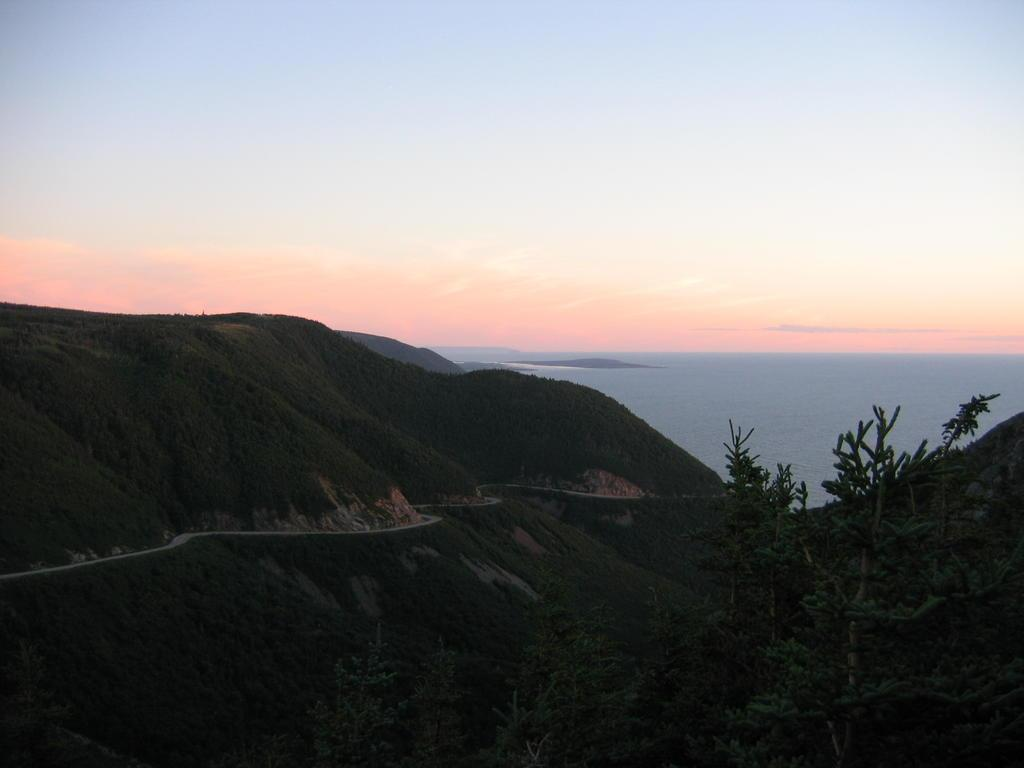What type of natural landscape is depicted in the image? The image features a group of trees, mountains, and water. What else can be seen in the sky in the image? The sky is visible in the image. What type of advertisement can be seen on the trees in the image? There are no advertisements present on the trees in the image. How many family members are visible in the image? There are no family members present in the image. 